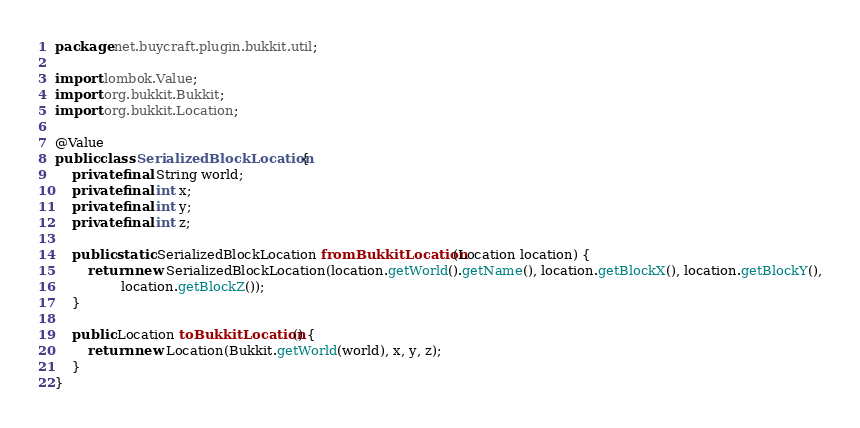Convert code to text. <code><loc_0><loc_0><loc_500><loc_500><_Java_>package net.buycraft.plugin.bukkit.util;

import lombok.Value;
import org.bukkit.Bukkit;
import org.bukkit.Location;

@Value
public class SerializedBlockLocation {
    private final String world;
    private final int x;
    private final int y;
    private final int z;

    public static SerializedBlockLocation fromBukkitLocation(Location location) {
        return new SerializedBlockLocation(location.getWorld().getName(), location.getBlockX(), location.getBlockY(),
                location.getBlockZ());
    }

    public Location toBukkitLocation() {
        return new Location(Bukkit.getWorld(world), x, y, z);
    }
}
</code> 